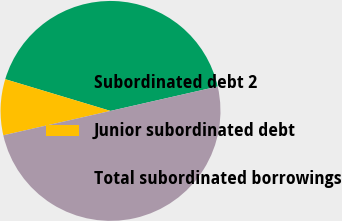<chart> <loc_0><loc_0><loc_500><loc_500><pie_chart><fcel>Subordinated debt 2<fcel>Junior subordinated debt<fcel>Total subordinated borrowings<nl><fcel>41.78%<fcel>8.22%<fcel>50.0%<nl></chart> 